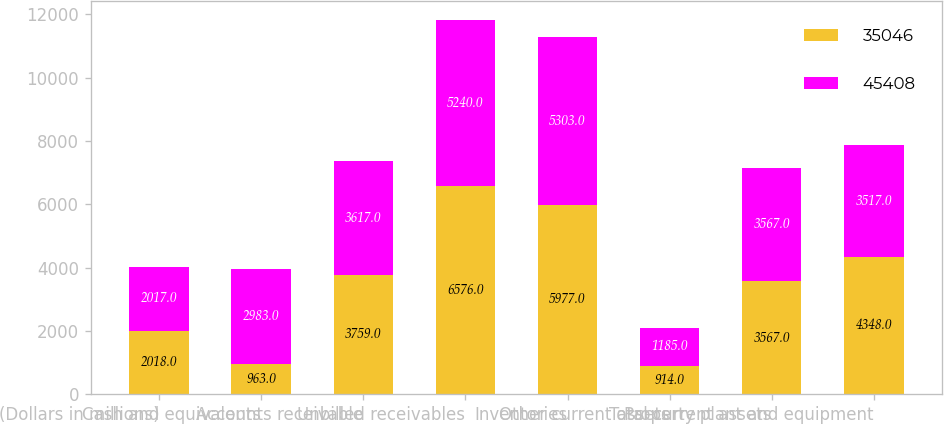Convert chart to OTSL. <chart><loc_0><loc_0><loc_500><loc_500><stacked_bar_chart><ecel><fcel>(Dollars in millions)<fcel>Cash and equivalents<fcel>Accounts receivable<fcel>Unbilled receivables<fcel>Inventories<fcel>Other current assets<fcel>Total current assets<fcel>Property plant and equipment<nl><fcel>35046<fcel>2018<fcel>963<fcel>3759<fcel>6576<fcel>5977<fcel>914<fcel>3567<fcel>4348<nl><fcel>45408<fcel>2017<fcel>2983<fcel>3617<fcel>5240<fcel>5303<fcel>1185<fcel>3567<fcel>3517<nl></chart> 